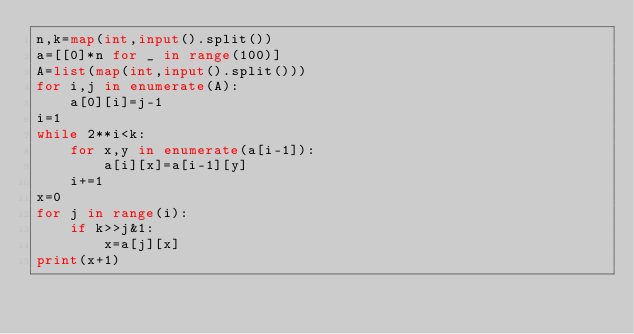Convert code to text. <code><loc_0><loc_0><loc_500><loc_500><_Python_>n,k=map(int,input().split())
a=[[0]*n for _ in range(100)]
A=list(map(int,input().split()))
for i,j in enumerate(A):
    a[0][i]=j-1
i=1
while 2**i<k:
    for x,y in enumerate(a[i-1]):
        a[i][x]=a[i-1][y]
    i+=1
x=0
for j in range(i):
    if k>>j&1:
        x=a[j][x]
print(x+1)</code> 